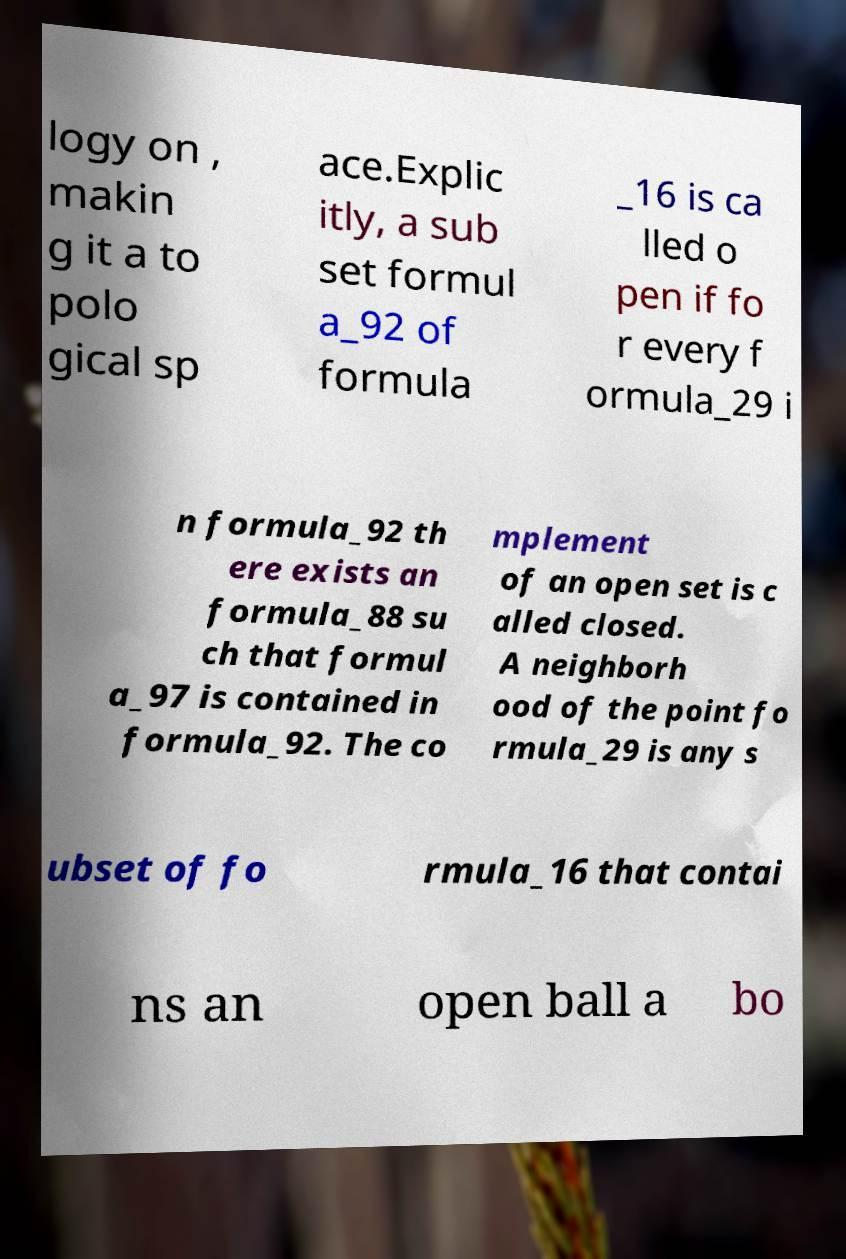There's text embedded in this image that I need extracted. Can you transcribe it verbatim? logy on , makin g it a to polo gical sp ace.Explic itly, a sub set formul a_92 of formula _16 is ca lled o pen if fo r every f ormula_29 i n formula_92 th ere exists an formula_88 su ch that formul a_97 is contained in formula_92. The co mplement of an open set is c alled closed. A neighborh ood of the point fo rmula_29 is any s ubset of fo rmula_16 that contai ns an open ball a bo 